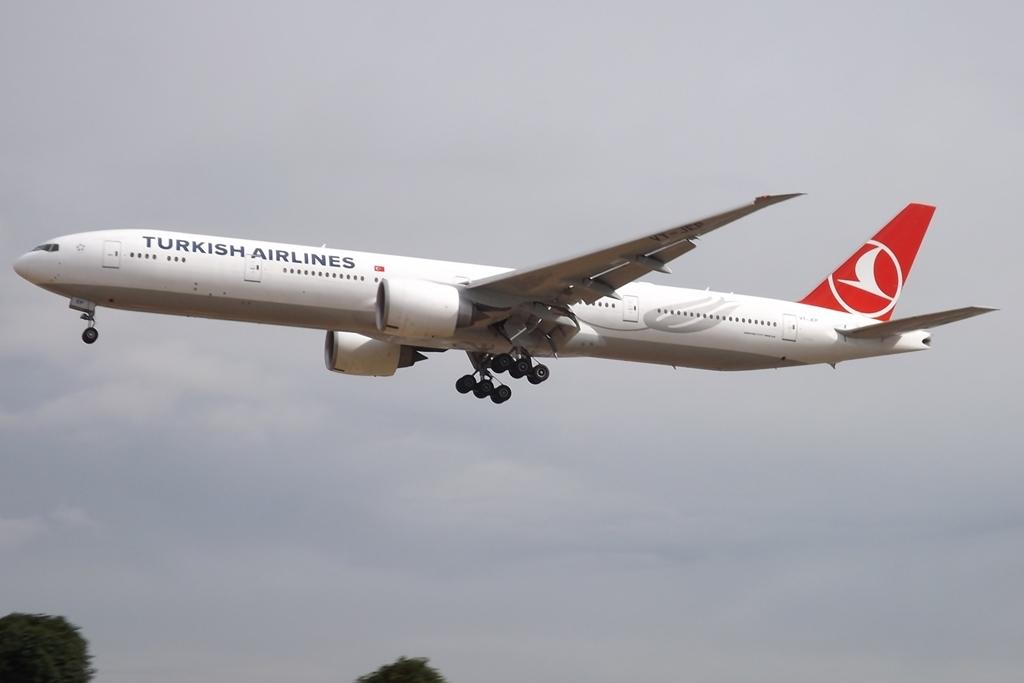What is the main subject of the image? The main subject of the image is an airplane flying. What is the setting of the image? The image depiction of the sky suggests that the image is set in the air. What can be seen at the bottom of the image? There are trees at the bottom of the image. What type of spark can be seen coming from the trees in the image? There is no spark present in the image; it only features an airplane flying in the sky and trees at the bottom. 